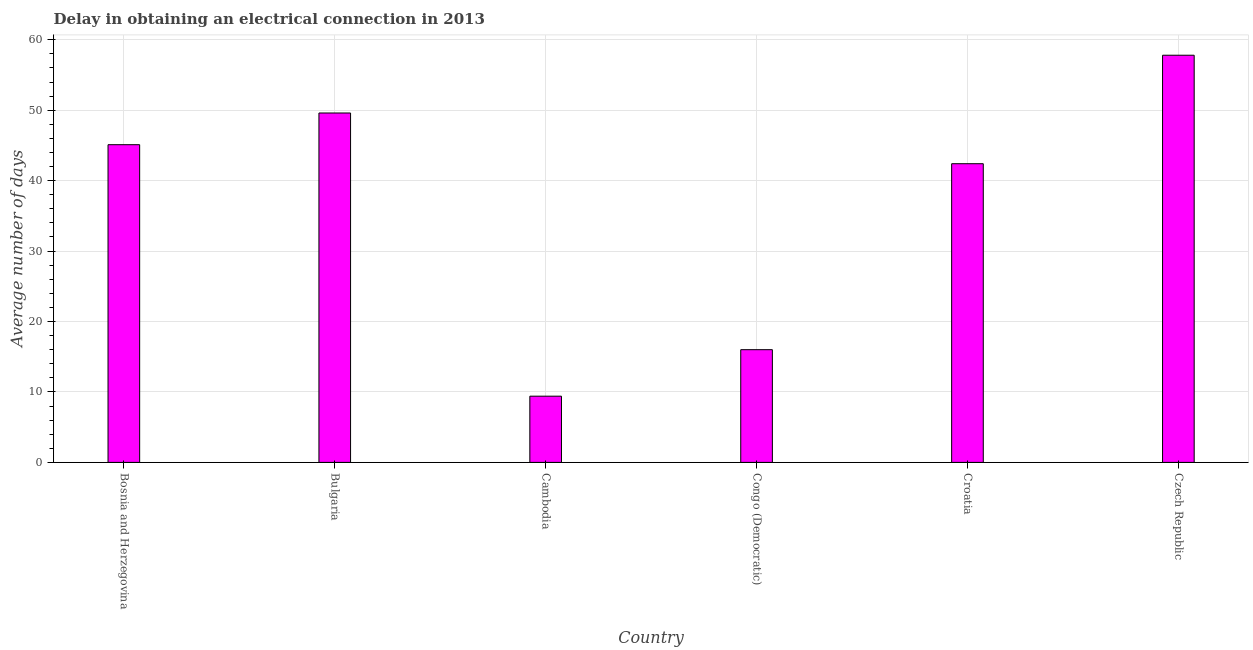Does the graph contain any zero values?
Provide a succinct answer. No. Does the graph contain grids?
Provide a short and direct response. Yes. What is the title of the graph?
Offer a terse response. Delay in obtaining an electrical connection in 2013. What is the label or title of the Y-axis?
Provide a short and direct response. Average number of days. What is the dalay in electrical connection in Croatia?
Your answer should be very brief. 42.4. Across all countries, what is the maximum dalay in electrical connection?
Provide a succinct answer. 57.8. Across all countries, what is the minimum dalay in electrical connection?
Your response must be concise. 9.4. In which country was the dalay in electrical connection maximum?
Offer a terse response. Czech Republic. In which country was the dalay in electrical connection minimum?
Make the answer very short. Cambodia. What is the sum of the dalay in electrical connection?
Make the answer very short. 220.3. What is the difference between the dalay in electrical connection in Bosnia and Herzegovina and Bulgaria?
Keep it short and to the point. -4.5. What is the average dalay in electrical connection per country?
Keep it short and to the point. 36.72. What is the median dalay in electrical connection?
Ensure brevity in your answer.  43.75. In how many countries, is the dalay in electrical connection greater than 34 days?
Your answer should be very brief. 4. What is the ratio of the dalay in electrical connection in Bosnia and Herzegovina to that in Czech Republic?
Your response must be concise. 0.78. Is the dalay in electrical connection in Cambodia less than that in Czech Republic?
Keep it short and to the point. Yes. What is the difference between the highest and the second highest dalay in electrical connection?
Make the answer very short. 8.2. Is the sum of the dalay in electrical connection in Cambodia and Congo (Democratic) greater than the maximum dalay in electrical connection across all countries?
Make the answer very short. No. What is the difference between the highest and the lowest dalay in electrical connection?
Make the answer very short. 48.4. In how many countries, is the dalay in electrical connection greater than the average dalay in electrical connection taken over all countries?
Give a very brief answer. 4. What is the difference between two consecutive major ticks on the Y-axis?
Your answer should be very brief. 10. Are the values on the major ticks of Y-axis written in scientific E-notation?
Give a very brief answer. No. What is the Average number of days in Bosnia and Herzegovina?
Keep it short and to the point. 45.1. What is the Average number of days of Bulgaria?
Make the answer very short. 49.6. What is the Average number of days of Cambodia?
Offer a very short reply. 9.4. What is the Average number of days in Congo (Democratic)?
Make the answer very short. 16. What is the Average number of days of Croatia?
Make the answer very short. 42.4. What is the Average number of days of Czech Republic?
Offer a very short reply. 57.8. What is the difference between the Average number of days in Bosnia and Herzegovina and Bulgaria?
Provide a short and direct response. -4.5. What is the difference between the Average number of days in Bosnia and Herzegovina and Cambodia?
Offer a terse response. 35.7. What is the difference between the Average number of days in Bosnia and Herzegovina and Congo (Democratic)?
Give a very brief answer. 29.1. What is the difference between the Average number of days in Bosnia and Herzegovina and Croatia?
Keep it short and to the point. 2.7. What is the difference between the Average number of days in Bosnia and Herzegovina and Czech Republic?
Your response must be concise. -12.7. What is the difference between the Average number of days in Bulgaria and Cambodia?
Provide a short and direct response. 40.2. What is the difference between the Average number of days in Bulgaria and Congo (Democratic)?
Your answer should be very brief. 33.6. What is the difference between the Average number of days in Bulgaria and Croatia?
Offer a terse response. 7.2. What is the difference between the Average number of days in Cambodia and Congo (Democratic)?
Your response must be concise. -6.6. What is the difference between the Average number of days in Cambodia and Croatia?
Your response must be concise. -33. What is the difference between the Average number of days in Cambodia and Czech Republic?
Your answer should be compact. -48.4. What is the difference between the Average number of days in Congo (Democratic) and Croatia?
Offer a terse response. -26.4. What is the difference between the Average number of days in Congo (Democratic) and Czech Republic?
Offer a very short reply. -41.8. What is the difference between the Average number of days in Croatia and Czech Republic?
Your response must be concise. -15.4. What is the ratio of the Average number of days in Bosnia and Herzegovina to that in Bulgaria?
Your answer should be compact. 0.91. What is the ratio of the Average number of days in Bosnia and Herzegovina to that in Cambodia?
Keep it short and to the point. 4.8. What is the ratio of the Average number of days in Bosnia and Herzegovina to that in Congo (Democratic)?
Your answer should be compact. 2.82. What is the ratio of the Average number of days in Bosnia and Herzegovina to that in Croatia?
Your response must be concise. 1.06. What is the ratio of the Average number of days in Bosnia and Herzegovina to that in Czech Republic?
Your response must be concise. 0.78. What is the ratio of the Average number of days in Bulgaria to that in Cambodia?
Ensure brevity in your answer.  5.28. What is the ratio of the Average number of days in Bulgaria to that in Congo (Democratic)?
Ensure brevity in your answer.  3.1. What is the ratio of the Average number of days in Bulgaria to that in Croatia?
Keep it short and to the point. 1.17. What is the ratio of the Average number of days in Bulgaria to that in Czech Republic?
Ensure brevity in your answer.  0.86. What is the ratio of the Average number of days in Cambodia to that in Congo (Democratic)?
Give a very brief answer. 0.59. What is the ratio of the Average number of days in Cambodia to that in Croatia?
Keep it short and to the point. 0.22. What is the ratio of the Average number of days in Cambodia to that in Czech Republic?
Your response must be concise. 0.16. What is the ratio of the Average number of days in Congo (Democratic) to that in Croatia?
Offer a terse response. 0.38. What is the ratio of the Average number of days in Congo (Democratic) to that in Czech Republic?
Offer a very short reply. 0.28. What is the ratio of the Average number of days in Croatia to that in Czech Republic?
Offer a very short reply. 0.73. 